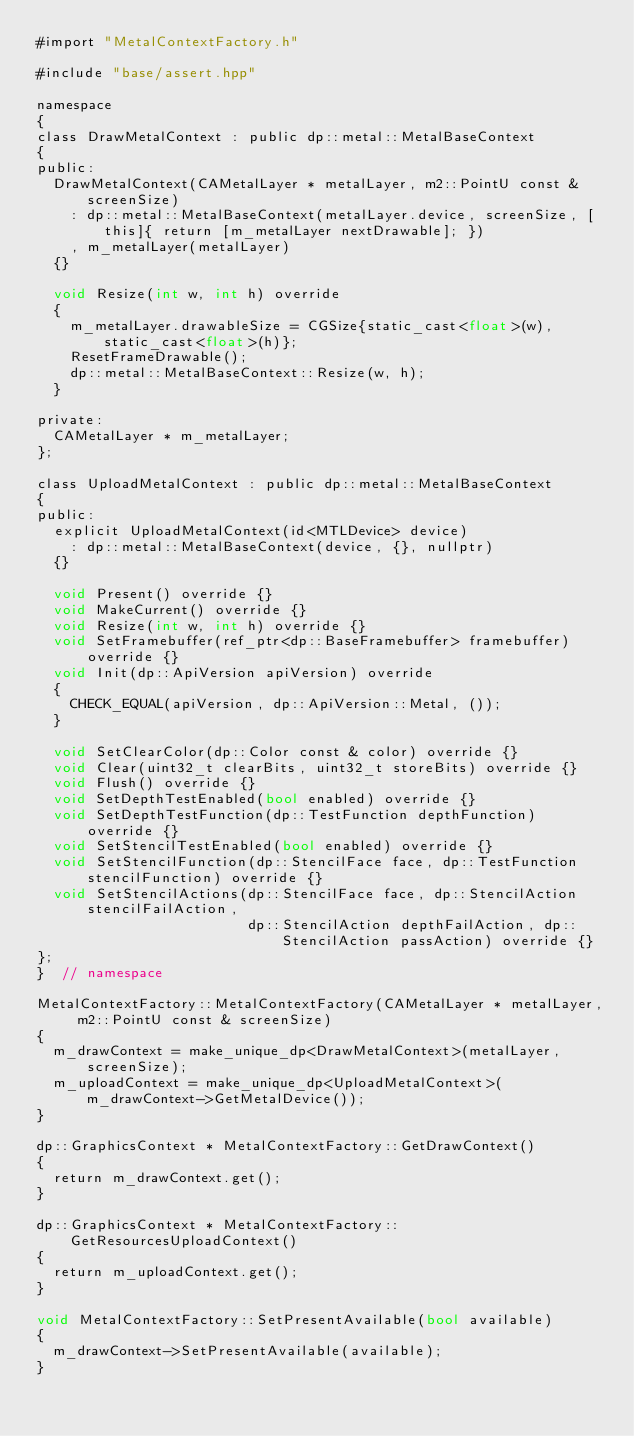Convert code to text. <code><loc_0><loc_0><loc_500><loc_500><_ObjectiveC_>#import "MetalContextFactory.h"

#include "base/assert.hpp"

namespace
{
class DrawMetalContext : public dp::metal::MetalBaseContext
{
public:
  DrawMetalContext(CAMetalLayer * metalLayer, m2::PointU const & screenSize)
    : dp::metal::MetalBaseContext(metalLayer.device, screenSize, [this]{ return [m_metalLayer nextDrawable]; })
    , m_metalLayer(metalLayer)
  {}
  
  void Resize(int w, int h) override
  {
    m_metalLayer.drawableSize = CGSize{static_cast<float>(w), static_cast<float>(h)};
    ResetFrameDrawable();
    dp::metal::MetalBaseContext::Resize(w, h);
  }
  
private:
  CAMetalLayer * m_metalLayer;
};
  
class UploadMetalContext : public dp::metal::MetalBaseContext
{
public:
  explicit UploadMetalContext(id<MTLDevice> device)
    : dp::metal::MetalBaseContext(device, {}, nullptr)
  {}
  
  void Present() override {}
  void MakeCurrent() override {}
  void Resize(int w, int h) override {}
  void SetFramebuffer(ref_ptr<dp::BaseFramebuffer> framebuffer) override {}
  void Init(dp::ApiVersion apiVersion) override
  {
    CHECK_EQUAL(apiVersion, dp::ApiVersion::Metal, ());
  }
  
  void SetClearColor(dp::Color const & color) override {}
  void Clear(uint32_t clearBits, uint32_t storeBits) override {}
  void Flush() override {}
  void SetDepthTestEnabled(bool enabled) override {}
  void SetDepthTestFunction(dp::TestFunction depthFunction) override {}
  void SetStencilTestEnabled(bool enabled) override {}
  void SetStencilFunction(dp::StencilFace face, dp::TestFunction stencilFunction) override {}
  void SetStencilActions(dp::StencilFace face, dp::StencilAction stencilFailAction,
                         dp::StencilAction depthFailAction, dp::StencilAction passAction) override {}
};
}  // namespace

MetalContextFactory::MetalContextFactory(CAMetalLayer * metalLayer, m2::PointU const & screenSize)
{
  m_drawContext = make_unique_dp<DrawMetalContext>(metalLayer, screenSize);
  m_uploadContext = make_unique_dp<UploadMetalContext>(m_drawContext->GetMetalDevice());
}

dp::GraphicsContext * MetalContextFactory::GetDrawContext()
{
  return m_drawContext.get();
}

dp::GraphicsContext * MetalContextFactory::GetResourcesUploadContext()
{
  return m_uploadContext.get();
}

void MetalContextFactory::SetPresentAvailable(bool available)
{
  m_drawContext->SetPresentAvailable(available);
}
</code> 